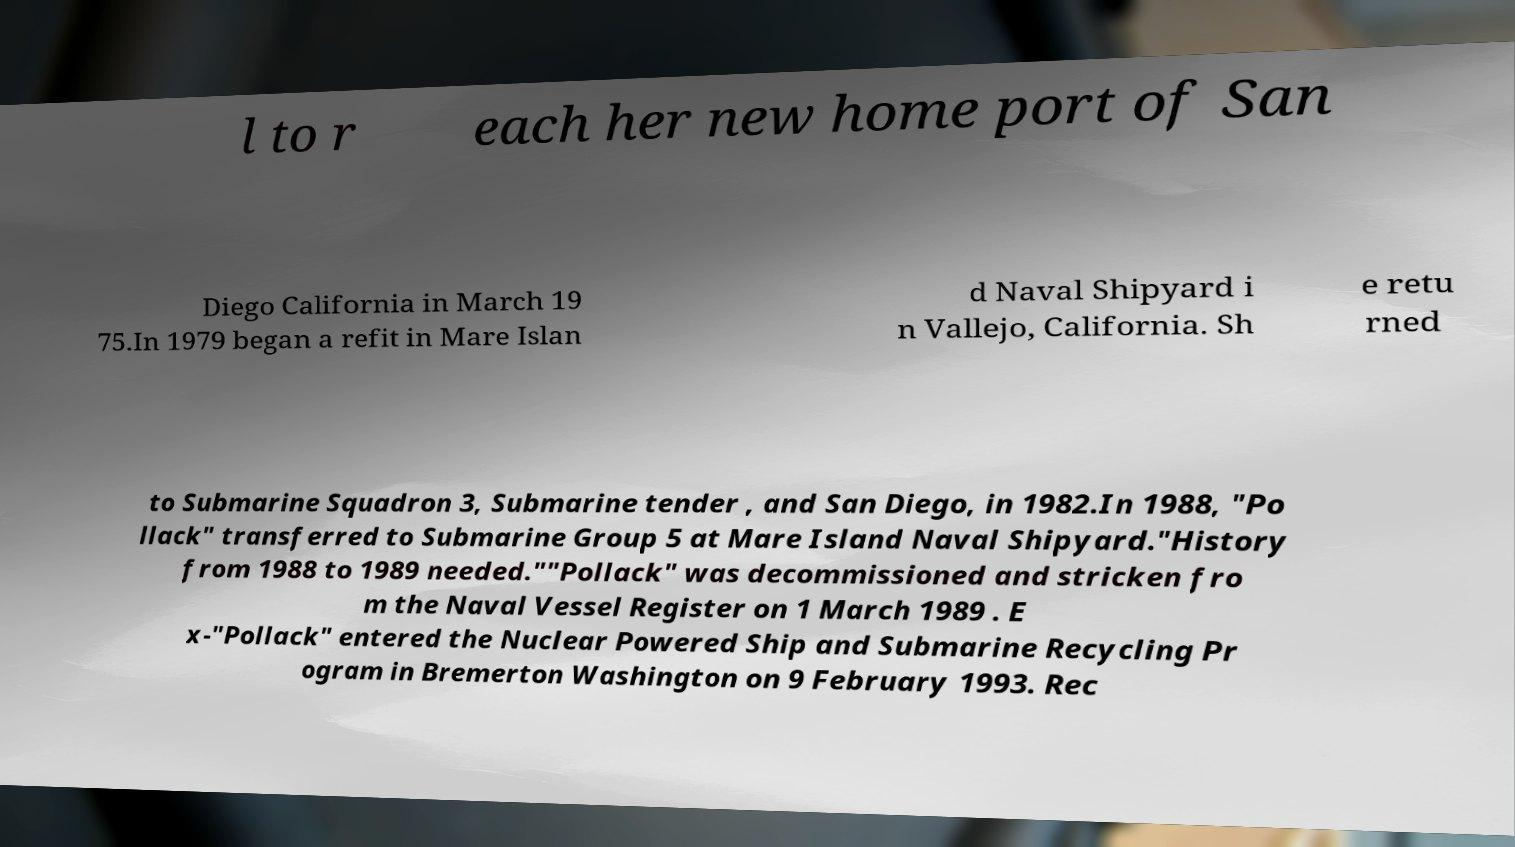Please read and relay the text visible in this image. What does it say? l to r each her new home port of San Diego California in March 19 75.In 1979 began a refit in Mare Islan d Naval Shipyard i n Vallejo, California. Sh e retu rned to Submarine Squadron 3, Submarine tender , and San Diego, in 1982.In 1988, "Po llack" transferred to Submarine Group 5 at Mare Island Naval Shipyard."History from 1988 to 1989 needed.""Pollack" was decommissioned and stricken fro m the Naval Vessel Register on 1 March 1989 . E x-"Pollack" entered the Nuclear Powered Ship and Submarine Recycling Pr ogram in Bremerton Washington on 9 February 1993. Rec 